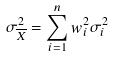<formula> <loc_0><loc_0><loc_500><loc_500>\sigma _ { \overline { X } } ^ { 2 } = \sum _ { i = 1 } ^ { n } w _ { i } ^ { 2 } \sigma _ { i } ^ { 2 }</formula> 